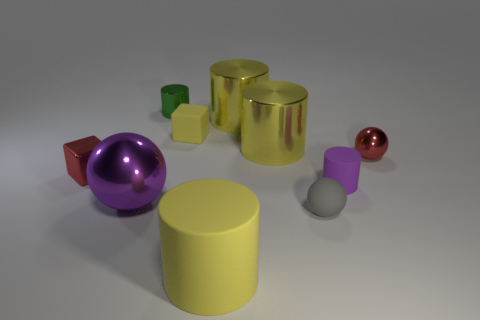There is a tiny red thing on the right side of the small yellow rubber cube; is its shape the same as the tiny green thing?
Provide a short and direct response. No. There is a large thing behind the tiny yellow rubber cube; what material is it?
Your answer should be compact. Metal. How many matte objects are either cubes or small blue blocks?
Offer a very short reply. 1. Are there any green things that have the same size as the purple rubber cylinder?
Your answer should be compact. Yes. Is the number of small cubes that are left of the green cylinder greater than the number of tiny yellow matte spheres?
Offer a terse response. Yes. What number of big objects are metal objects or gray rubber cylinders?
Ensure brevity in your answer.  3. How many other rubber objects have the same shape as the large yellow rubber thing?
Offer a very short reply. 1. The cube that is behind the red metallic object to the left of the purple rubber thing is made of what material?
Your answer should be compact. Rubber. There is a shiny ball that is right of the tiny gray ball; what is its size?
Keep it short and to the point. Small. How many yellow things are either tiny matte spheres or shiny cylinders?
Make the answer very short. 2. 